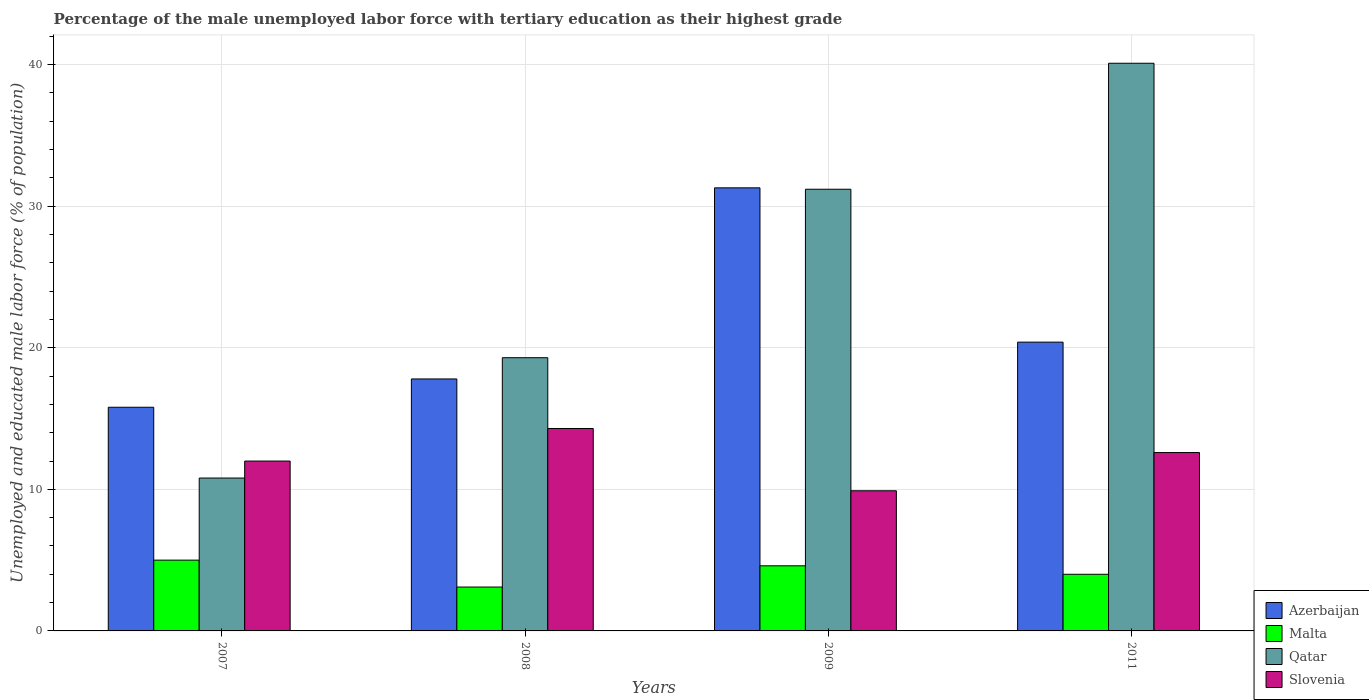How many different coloured bars are there?
Provide a succinct answer. 4. How many groups of bars are there?
Make the answer very short. 4. Are the number of bars per tick equal to the number of legend labels?
Make the answer very short. Yes. How many bars are there on the 3rd tick from the left?
Keep it short and to the point. 4. What is the percentage of the unemployed male labor force with tertiary education in Azerbaijan in 2008?
Ensure brevity in your answer.  17.8. Across all years, what is the maximum percentage of the unemployed male labor force with tertiary education in Qatar?
Ensure brevity in your answer.  40.1. Across all years, what is the minimum percentage of the unemployed male labor force with tertiary education in Slovenia?
Offer a terse response. 9.9. What is the total percentage of the unemployed male labor force with tertiary education in Malta in the graph?
Your answer should be compact. 16.7. What is the difference between the percentage of the unemployed male labor force with tertiary education in Azerbaijan in 2009 and that in 2011?
Make the answer very short. 10.9. What is the difference between the percentage of the unemployed male labor force with tertiary education in Azerbaijan in 2011 and the percentage of the unemployed male labor force with tertiary education in Qatar in 2009?
Your answer should be compact. -10.8. What is the average percentage of the unemployed male labor force with tertiary education in Azerbaijan per year?
Offer a very short reply. 21.32. In the year 2011, what is the difference between the percentage of the unemployed male labor force with tertiary education in Qatar and percentage of the unemployed male labor force with tertiary education in Malta?
Provide a short and direct response. 36.1. What is the ratio of the percentage of the unemployed male labor force with tertiary education in Qatar in 2007 to that in 2009?
Provide a succinct answer. 0.35. What is the difference between the highest and the second highest percentage of the unemployed male labor force with tertiary education in Qatar?
Your response must be concise. 8.9. What is the difference between the highest and the lowest percentage of the unemployed male labor force with tertiary education in Azerbaijan?
Your answer should be compact. 15.5. In how many years, is the percentage of the unemployed male labor force with tertiary education in Azerbaijan greater than the average percentage of the unemployed male labor force with tertiary education in Azerbaijan taken over all years?
Offer a very short reply. 1. What does the 1st bar from the left in 2011 represents?
Provide a short and direct response. Azerbaijan. What does the 3rd bar from the right in 2009 represents?
Your response must be concise. Malta. How many bars are there?
Make the answer very short. 16. How many years are there in the graph?
Give a very brief answer. 4. How are the legend labels stacked?
Offer a very short reply. Vertical. What is the title of the graph?
Your answer should be very brief. Percentage of the male unemployed labor force with tertiary education as their highest grade. Does "Sri Lanka" appear as one of the legend labels in the graph?
Provide a short and direct response. No. What is the label or title of the Y-axis?
Make the answer very short. Unemployed and educated male labor force (% of population). What is the Unemployed and educated male labor force (% of population) of Azerbaijan in 2007?
Make the answer very short. 15.8. What is the Unemployed and educated male labor force (% of population) of Malta in 2007?
Make the answer very short. 5. What is the Unemployed and educated male labor force (% of population) in Qatar in 2007?
Offer a very short reply. 10.8. What is the Unemployed and educated male labor force (% of population) of Azerbaijan in 2008?
Provide a succinct answer. 17.8. What is the Unemployed and educated male labor force (% of population) of Malta in 2008?
Your answer should be compact. 3.1. What is the Unemployed and educated male labor force (% of population) of Qatar in 2008?
Your response must be concise. 19.3. What is the Unemployed and educated male labor force (% of population) of Slovenia in 2008?
Offer a terse response. 14.3. What is the Unemployed and educated male labor force (% of population) in Azerbaijan in 2009?
Offer a terse response. 31.3. What is the Unemployed and educated male labor force (% of population) in Malta in 2009?
Ensure brevity in your answer.  4.6. What is the Unemployed and educated male labor force (% of population) in Qatar in 2009?
Your answer should be very brief. 31.2. What is the Unemployed and educated male labor force (% of population) of Slovenia in 2009?
Provide a succinct answer. 9.9. What is the Unemployed and educated male labor force (% of population) in Azerbaijan in 2011?
Offer a very short reply. 20.4. What is the Unemployed and educated male labor force (% of population) of Malta in 2011?
Make the answer very short. 4. What is the Unemployed and educated male labor force (% of population) in Qatar in 2011?
Provide a short and direct response. 40.1. What is the Unemployed and educated male labor force (% of population) of Slovenia in 2011?
Offer a terse response. 12.6. Across all years, what is the maximum Unemployed and educated male labor force (% of population) of Azerbaijan?
Your response must be concise. 31.3. Across all years, what is the maximum Unemployed and educated male labor force (% of population) of Qatar?
Offer a very short reply. 40.1. Across all years, what is the maximum Unemployed and educated male labor force (% of population) in Slovenia?
Your answer should be very brief. 14.3. Across all years, what is the minimum Unemployed and educated male labor force (% of population) of Azerbaijan?
Offer a very short reply. 15.8. Across all years, what is the minimum Unemployed and educated male labor force (% of population) of Malta?
Keep it short and to the point. 3.1. Across all years, what is the minimum Unemployed and educated male labor force (% of population) in Qatar?
Provide a short and direct response. 10.8. Across all years, what is the minimum Unemployed and educated male labor force (% of population) in Slovenia?
Your answer should be very brief. 9.9. What is the total Unemployed and educated male labor force (% of population) in Azerbaijan in the graph?
Provide a succinct answer. 85.3. What is the total Unemployed and educated male labor force (% of population) in Malta in the graph?
Keep it short and to the point. 16.7. What is the total Unemployed and educated male labor force (% of population) of Qatar in the graph?
Your answer should be compact. 101.4. What is the total Unemployed and educated male labor force (% of population) in Slovenia in the graph?
Give a very brief answer. 48.8. What is the difference between the Unemployed and educated male labor force (% of population) in Malta in 2007 and that in 2008?
Provide a succinct answer. 1.9. What is the difference between the Unemployed and educated male labor force (% of population) of Qatar in 2007 and that in 2008?
Ensure brevity in your answer.  -8.5. What is the difference between the Unemployed and educated male labor force (% of population) in Azerbaijan in 2007 and that in 2009?
Your answer should be compact. -15.5. What is the difference between the Unemployed and educated male labor force (% of population) of Malta in 2007 and that in 2009?
Provide a succinct answer. 0.4. What is the difference between the Unemployed and educated male labor force (% of population) of Qatar in 2007 and that in 2009?
Offer a terse response. -20.4. What is the difference between the Unemployed and educated male labor force (% of population) in Azerbaijan in 2007 and that in 2011?
Give a very brief answer. -4.6. What is the difference between the Unemployed and educated male labor force (% of population) of Qatar in 2007 and that in 2011?
Give a very brief answer. -29.3. What is the difference between the Unemployed and educated male labor force (% of population) of Slovenia in 2007 and that in 2011?
Your answer should be compact. -0.6. What is the difference between the Unemployed and educated male labor force (% of population) of Qatar in 2008 and that in 2009?
Your answer should be very brief. -11.9. What is the difference between the Unemployed and educated male labor force (% of population) of Slovenia in 2008 and that in 2009?
Offer a terse response. 4.4. What is the difference between the Unemployed and educated male labor force (% of population) of Malta in 2008 and that in 2011?
Your answer should be very brief. -0.9. What is the difference between the Unemployed and educated male labor force (% of population) in Qatar in 2008 and that in 2011?
Keep it short and to the point. -20.8. What is the difference between the Unemployed and educated male labor force (% of population) of Slovenia in 2008 and that in 2011?
Offer a terse response. 1.7. What is the difference between the Unemployed and educated male labor force (% of population) in Azerbaijan in 2009 and that in 2011?
Your answer should be compact. 10.9. What is the difference between the Unemployed and educated male labor force (% of population) of Malta in 2009 and that in 2011?
Make the answer very short. 0.6. What is the difference between the Unemployed and educated male labor force (% of population) in Slovenia in 2009 and that in 2011?
Your response must be concise. -2.7. What is the difference between the Unemployed and educated male labor force (% of population) of Azerbaijan in 2007 and the Unemployed and educated male labor force (% of population) of Malta in 2008?
Make the answer very short. 12.7. What is the difference between the Unemployed and educated male labor force (% of population) in Malta in 2007 and the Unemployed and educated male labor force (% of population) in Qatar in 2008?
Your answer should be compact. -14.3. What is the difference between the Unemployed and educated male labor force (% of population) in Azerbaijan in 2007 and the Unemployed and educated male labor force (% of population) in Qatar in 2009?
Make the answer very short. -15.4. What is the difference between the Unemployed and educated male labor force (% of population) in Malta in 2007 and the Unemployed and educated male labor force (% of population) in Qatar in 2009?
Your answer should be compact. -26.2. What is the difference between the Unemployed and educated male labor force (% of population) of Qatar in 2007 and the Unemployed and educated male labor force (% of population) of Slovenia in 2009?
Your answer should be compact. 0.9. What is the difference between the Unemployed and educated male labor force (% of population) in Azerbaijan in 2007 and the Unemployed and educated male labor force (% of population) in Malta in 2011?
Your answer should be compact. 11.8. What is the difference between the Unemployed and educated male labor force (% of population) in Azerbaijan in 2007 and the Unemployed and educated male labor force (% of population) in Qatar in 2011?
Make the answer very short. -24.3. What is the difference between the Unemployed and educated male labor force (% of population) of Azerbaijan in 2007 and the Unemployed and educated male labor force (% of population) of Slovenia in 2011?
Keep it short and to the point. 3.2. What is the difference between the Unemployed and educated male labor force (% of population) of Malta in 2007 and the Unemployed and educated male labor force (% of population) of Qatar in 2011?
Make the answer very short. -35.1. What is the difference between the Unemployed and educated male labor force (% of population) in Malta in 2007 and the Unemployed and educated male labor force (% of population) in Slovenia in 2011?
Your answer should be compact. -7.6. What is the difference between the Unemployed and educated male labor force (% of population) in Qatar in 2007 and the Unemployed and educated male labor force (% of population) in Slovenia in 2011?
Offer a terse response. -1.8. What is the difference between the Unemployed and educated male labor force (% of population) in Azerbaijan in 2008 and the Unemployed and educated male labor force (% of population) in Qatar in 2009?
Your answer should be very brief. -13.4. What is the difference between the Unemployed and educated male labor force (% of population) in Malta in 2008 and the Unemployed and educated male labor force (% of population) in Qatar in 2009?
Give a very brief answer. -28.1. What is the difference between the Unemployed and educated male labor force (% of population) in Qatar in 2008 and the Unemployed and educated male labor force (% of population) in Slovenia in 2009?
Provide a succinct answer. 9.4. What is the difference between the Unemployed and educated male labor force (% of population) of Azerbaijan in 2008 and the Unemployed and educated male labor force (% of population) of Qatar in 2011?
Your response must be concise. -22.3. What is the difference between the Unemployed and educated male labor force (% of population) in Azerbaijan in 2008 and the Unemployed and educated male labor force (% of population) in Slovenia in 2011?
Offer a terse response. 5.2. What is the difference between the Unemployed and educated male labor force (% of population) in Malta in 2008 and the Unemployed and educated male labor force (% of population) in Qatar in 2011?
Your response must be concise. -37. What is the difference between the Unemployed and educated male labor force (% of population) of Qatar in 2008 and the Unemployed and educated male labor force (% of population) of Slovenia in 2011?
Make the answer very short. 6.7. What is the difference between the Unemployed and educated male labor force (% of population) of Azerbaijan in 2009 and the Unemployed and educated male labor force (% of population) of Malta in 2011?
Keep it short and to the point. 27.3. What is the difference between the Unemployed and educated male labor force (% of population) in Azerbaijan in 2009 and the Unemployed and educated male labor force (% of population) in Slovenia in 2011?
Offer a very short reply. 18.7. What is the difference between the Unemployed and educated male labor force (% of population) of Malta in 2009 and the Unemployed and educated male labor force (% of population) of Qatar in 2011?
Make the answer very short. -35.5. What is the difference between the Unemployed and educated male labor force (% of population) in Malta in 2009 and the Unemployed and educated male labor force (% of population) in Slovenia in 2011?
Give a very brief answer. -8. What is the average Unemployed and educated male labor force (% of population) in Azerbaijan per year?
Provide a succinct answer. 21.32. What is the average Unemployed and educated male labor force (% of population) of Malta per year?
Offer a very short reply. 4.17. What is the average Unemployed and educated male labor force (% of population) in Qatar per year?
Keep it short and to the point. 25.35. What is the average Unemployed and educated male labor force (% of population) in Slovenia per year?
Your answer should be very brief. 12.2. In the year 2007, what is the difference between the Unemployed and educated male labor force (% of population) in Azerbaijan and Unemployed and educated male labor force (% of population) in Slovenia?
Offer a very short reply. 3.8. In the year 2007, what is the difference between the Unemployed and educated male labor force (% of population) of Malta and Unemployed and educated male labor force (% of population) of Qatar?
Make the answer very short. -5.8. In the year 2007, what is the difference between the Unemployed and educated male labor force (% of population) in Malta and Unemployed and educated male labor force (% of population) in Slovenia?
Your answer should be compact. -7. In the year 2007, what is the difference between the Unemployed and educated male labor force (% of population) in Qatar and Unemployed and educated male labor force (% of population) in Slovenia?
Offer a very short reply. -1.2. In the year 2008, what is the difference between the Unemployed and educated male labor force (% of population) of Azerbaijan and Unemployed and educated male labor force (% of population) of Qatar?
Provide a short and direct response. -1.5. In the year 2008, what is the difference between the Unemployed and educated male labor force (% of population) in Malta and Unemployed and educated male labor force (% of population) in Qatar?
Provide a short and direct response. -16.2. In the year 2008, what is the difference between the Unemployed and educated male labor force (% of population) in Malta and Unemployed and educated male labor force (% of population) in Slovenia?
Make the answer very short. -11.2. In the year 2008, what is the difference between the Unemployed and educated male labor force (% of population) of Qatar and Unemployed and educated male labor force (% of population) of Slovenia?
Keep it short and to the point. 5. In the year 2009, what is the difference between the Unemployed and educated male labor force (% of population) in Azerbaijan and Unemployed and educated male labor force (% of population) in Malta?
Offer a terse response. 26.7. In the year 2009, what is the difference between the Unemployed and educated male labor force (% of population) of Azerbaijan and Unemployed and educated male labor force (% of population) of Slovenia?
Offer a terse response. 21.4. In the year 2009, what is the difference between the Unemployed and educated male labor force (% of population) of Malta and Unemployed and educated male labor force (% of population) of Qatar?
Provide a short and direct response. -26.6. In the year 2009, what is the difference between the Unemployed and educated male labor force (% of population) in Malta and Unemployed and educated male labor force (% of population) in Slovenia?
Provide a succinct answer. -5.3. In the year 2009, what is the difference between the Unemployed and educated male labor force (% of population) in Qatar and Unemployed and educated male labor force (% of population) in Slovenia?
Your answer should be very brief. 21.3. In the year 2011, what is the difference between the Unemployed and educated male labor force (% of population) of Azerbaijan and Unemployed and educated male labor force (% of population) of Malta?
Your answer should be very brief. 16.4. In the year 2011, what is the difference between the Unemployed and educated male labor force (% of population) in Azerbaijan and Unemployed and educated male labor force (% of population) in Qatar?
Your answer should be very brief. -19.7. In the year 2011, what is the difference between the Unemployed and educated male labor force (% of population) in Malta and Unemployed and educated male labor force (% of population) in Qatar?
Give a very brief answer. -36.1. What is the ratio of the Unemployed and educated male labor force (% of population) of Azerbaijan in 2007 to that in 2008?
Your answer should be compact. 0.89. What is the ratio of the Unemployed and educated male labor force (% of population) of Malta in 2007 to that in 2008?
Make the answer very short. 1.61. What is the ratio of the Unemployed and educated male labor force (% of population) in Qatar in 2007 to that in 2008?
Your answer should be very brief. 0.56. What is the ratio of the Unemployed and educated male labor force (% of population) of Slovenia in 2007 to that in 2008?
Offer a very short reply. 0.84. What is the ratio of the Unemployed and educated male labor force (% of population) in Azerbaijan in 2007 to that in 2009?
Provide a short and direct response. 0.5. What is the ratio of the Unemployed and educated male labor force (% of population) in Malta in 2007 to that in 2009?
Provide a succinct answer. 1.09. What is the ratio of the Unemployed and educated male labor force (% of population) of Qatar in 2007 to that in 2009?
Offer a very short reply. 0.35. What is the ratio of the Unemployed and educated male labor force (% of population) in Slovenia in 2007 to that in 2009?
Give a very brief answer. 1.21. What is the ratio of the Unemployed and educated male labor force (% of population) of Azerbaijan in 2007 to that in 2011?
Keep it short and to the point. 0.77. What is the ratio of the Unemployed and educated male labor force (% of population) in Qatar in 2007 to that in 2011?
Offer a very short reply. 0.27. What is the ratio of the Unemployed and educated male labor force (% of population) in Slovenia in 2007 to that in 2011?
Ensure brevity in your answer.  0.95. What is the ratio of the Unemployed and educated male labor force (% of population) of Azerbaijan in 2008 to that in 2009?
Your response must be concise. 0.57. What is the ratio of the Unemployed and educated male labor force (% of population) in Malta in 2008 to that in 2009?
Make the answer very short. 0.67. What is the ratio of the Unemployed and educated male labor force (% of population) in Qatar in 2008 to that in 2009?
Your response must be concise. 0.62. What is the ratio of the Unemployed and educated male labor force (% of population) in Slovenia in 2008 to that in 2009?
Make the answer very short. 1.44. What is the ratio of the Unemployed and educated male labor force (% of population) in Azerbaijan in 2008 to that in 2011?
Your answer should be compact. 0.87. What is the ratio of the Unemployed and educated male labor force (% of population) of Malta in 2008 to that in 2011?
Your answer should be very brief. 0.78. What is the ratio of the Unemployed and educated male labor force (% of population) in Qatar in 2008 to that in 2011?
Keep it short and to the point. 0.48. What is the ratio of the Unemployed and educated male labor force (% of population) in Slovenia in 2008 to that in 2011?
Your answer should be compact. 1.13. What is the ratio of the Unemployed and educated male labor force (% of population) in Azerbaijan in 2009 to that in 2011?
Keep it short and to the point. 1.53. What is the ratio of the Unemployed and educated male labor force (% of population) of Malta in 2009 to that in 2011?
Provide a succinct answer. 1.15. What is the ratio of the Unemployed and educated male labor force (% of population) in Qatar in 2009 to that in 2011?
Offer a terse response. 0.78. What is the ratio of the Unemployed and educated male labor force (% of population) in Slovenia in 2009 to that in 2011?
Your response must be concise. 0.79. What is the difference between the highest and the second highest Unemployed and educated male labor force (% of population) of Azerbaijan?
Your response must be concise. 10.9. What is the difference between the highest and the second highest Unemployed and educated male labor force (% of population) in Qatar?
Provide a succinct answer. 8.9. What is the difference between the highest and the lowest Unemployed and educated male labor force (% of population) of Azerbaijan?
Keep it short and to the point. 15.5. What is the difference between the highest and the lowest Unemployed and educated male labor force (% of population) of Qatar?
Offer a terse response. 29.3. 